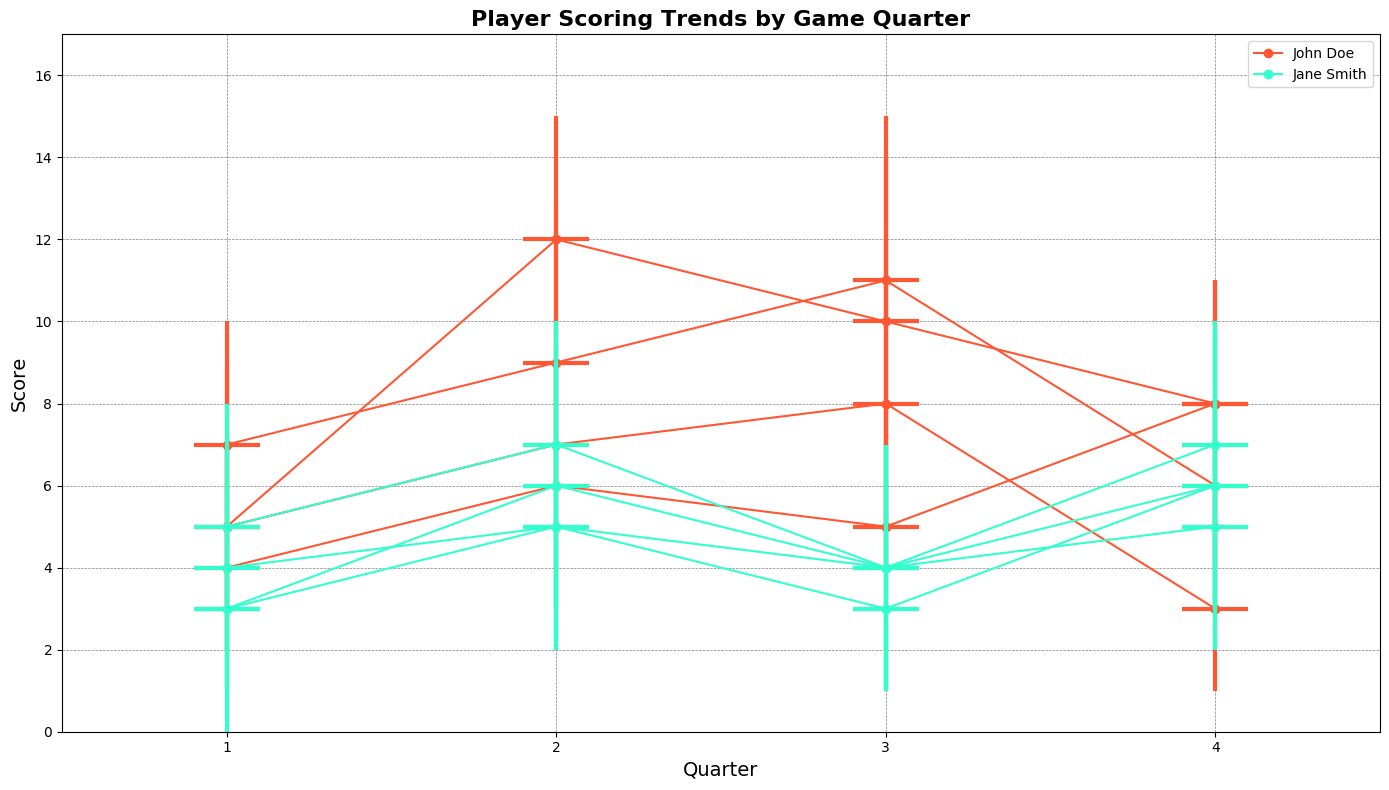What is the overall scoring trend for John Doe in the 4th quarter across all games? By examining the candlesticks for John Doe in the 4th quarter, you can see the median (Q1_Score) scores and the range of scores (Min_Score to Max_Score) for each game. On January 10, his Q1_Score was 8, on January 15 it was 6, on January 20 it was 8, and on January 25 it was 3. This indicates a fluctuating performance with his scores peaking on January 10 and January 20. The general trend shows variation without a clear upward or downward progression.
Answer: Fluctuating Which player had a more stable scoring range in the 1st quarter across all games? By comparing the vertical lines (score range) for both players in the 1st quarter across all games visually, it's evident that Jane Smith generally had a smaller range between her Min_Score and Max_Score values compared to John Doe. John Doe's scores varied more widely (e.g., from 2 to 9 on January 10 and from 1 to 7 on January 20), whereas Jane Smith's variations were less extreme (e.g., from 1 to 5 on January 10 and from 0 to 4 on January 20).
Answer: Jane Smith During which game did John Doe have the highest single quarter score? The highest single quarter score for John Doe can be determined by looking at the highest point on the vertical candlestick, which represents the Max_Score. For John Doe, January 15 in the 3rd quarter shows his highest Max_Score of 15 points.
Answer: January 15 Between Jane Smith and John Doe, who had a wider scoring range in the 2nd quarter across all games? The scoring range is represented by the vertical span between the Min_Score and Max_Score. In the 2nd quarter, for Jane Smith, her recored ranges were smaller, for instance, on January 10 (2 to 9), January 15 (3 to 10), January 20 (2 to 7), and January 25 (2 to 9). John Doe's ranges were larger, for example, on January 10 (6 to 15), January 15 (4 to 13), January 20 (3 to 9), and January 25 (3 to 10). This demonstrates that John Doe had a wider range in his scores.
Answer: John Doe How did Jane Smith's scoring performance vary in the 3rd quarter across all games? Visualizing the candlesticks for Jane Smith in the 3rd quarter, her Q1_Scores were as follows: January 10 (4), January 15 (4), January 20 (3), January 25 (4). Her scores show consistency with slight variations in the median score. The ranges also reflect limited fluctuation and smaller deviations from the median score apart from January 10 and January 25 ranges extending to 7.
Answer: Slightly varying but generally consistent Who showed a more consistent median scoring trend across quarters in all games? By focusing on the horizontal line within each candlestick, which shows Q1_Score, for both players across all quarters, Jane Smith's median scores appear more consistent across quarters and games, showing smaller variations. John Doe's medians (Q1_Scores) showed more noticeable fluctuations.
Answer: Jane Smith 